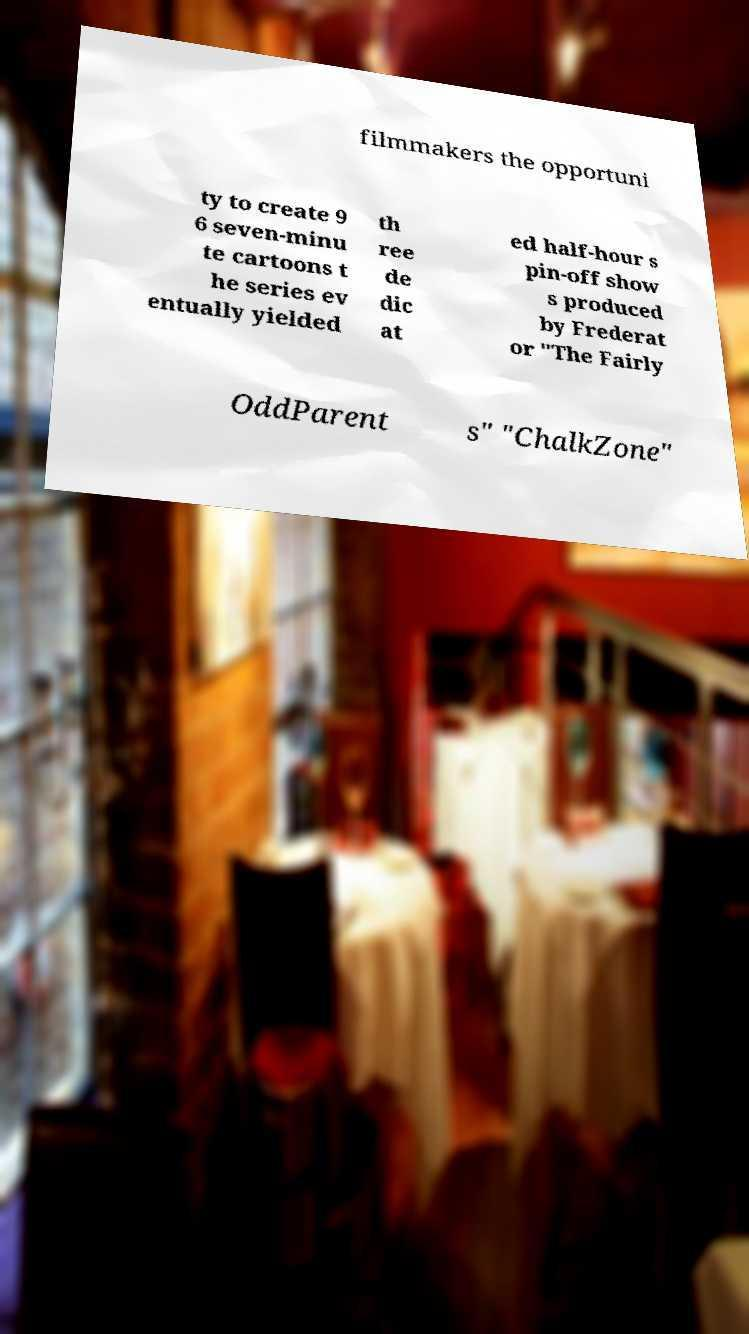What messages or text are displayed in this image? I need them in a readable, typed format. filmmakers the opportuni ty to create 9 6 seven-minu te cartoons t he series ev entually yielded th ree de dic at ed half-hour s pin-off show s produced by Frederat or "The Fairly OddParent s" "ChalkZone" 